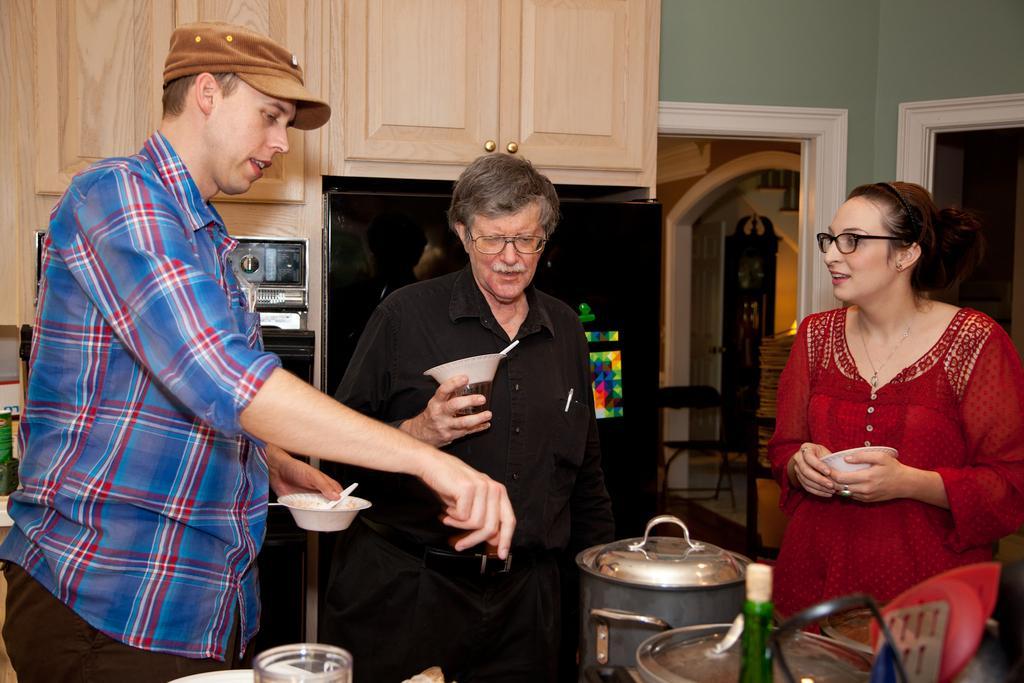In one or two sentences, can you explain what this image depicts? In this image we can see there are three people standing and holding bowl with spoon in their hand, in front of them there are some kitchen utensils, behind them there is a refrigerator, oven and cupboards. 